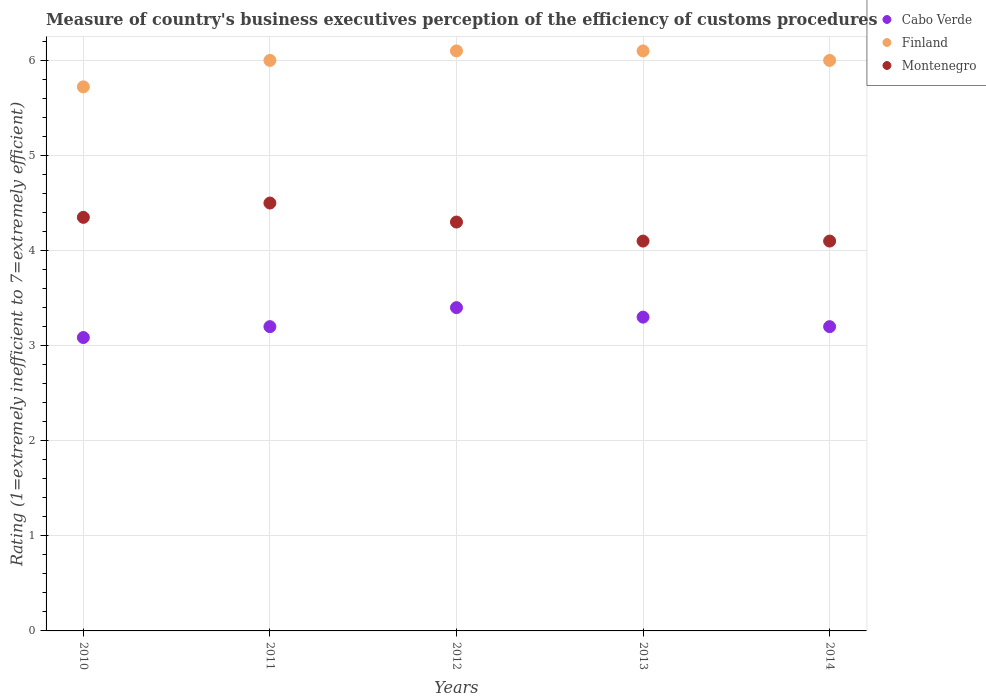What is the rating of the efficiency of customs procedure in Finland in 2011?
Your answer should be compact. 6. Across all years, what is the minimum rating of the efficiency of customs procedure in Cabo Verde?
Ensure brevity in your answer.  3.09. In which year was the rating of the efficiency of customs procedure in Finland maximum?
Ensure brevity in your answer.  2012. In which year was the rating of the efficiency of customs procedure in Cabo Verde minimum?
Offer a terse response. 2010. What is the total rating of the efficiency of customs procedure in Finland in the graph?
Keep it short and to the point. 29.92. What is the difference between the rating of the efficiency of customs procedure in Montenegro in 2011 and the rating of the efficiency of customs procedure in Cabo Verde in 2014?
Give a very brief answer. 1.3. What is the average rating of the efficiency of customs procedure in Montenegro per year?
Keep it short and to the point. 4.27. In the year 2011, what is the difference between the rating of the efficiency of customs procedure in Finland and rating of the efficiency of customs procedure in Cabo Verde?
Your answer should be very brief. 2.8. In how many years, is the rating of the efficiency of customs procedure in Montenegro greater than 5.4?
Make the answer very short. 0. What is the ratio of the rating of the efficiency of customs procedure in Finland in 2013 to that in 2014?
Provide a succinct answer. 1.02. Is the rating of the efficiency of customs procedure in Finland in 2010 less than that in 2011?
Provide a short and direct response. Yes. What is the difference between the highest and the lowest rating of the efficiency of customs procedure in Cabo Verde?
Make the answer very short. 0.31. In how many years, is the rating of the efficiency of customs procedure in Cabo Verde greater than the average rating of the efficiency of customs procedure in Cabo Verde taken over all years?
Offer a very short reply. 2. Is the sum of the rating of the efficiency of customs procedure in Finland in 2011 and 2014 greater than the maximum rating of the efficiency of customs procedure in Cabo Verde across all years?
Give a very brief answer. Yes. Does the rating of the efficiency of customs procedure in Finland monotonically increase over the years?
Offer a very short reply. No. Is the rating of the efficiency of customs procedure in Finland strictly less than the rating of the efficiency of customs procedure in Montenegro over the years?
Offer a very short reply. No. How many dotlines are there?
Provide a succinct answer. 3. Are the values on the major ticks of Y-axis written in scientific E-notation?
Give a very brief answer. No. Does the graph contain any zero values?
Offer a very short reply. No. Does the graph contain grids?
Keep it short and to the point. Yes. How many legend labels are there?
Make the answer very short. 3. What is the title of the graph?
Provide a short and direct response. Measure of country's business executives perception of the efficiency of customs procedures. What is the label or title of the Y-axis?
Your response must be concise. Rating (1=extremely inefficient to 7=extremely efficient). What is the Rating (1=extremely inefficient to 7=extremely efficient) of Cabo Verde in 2010?
Your answer should be compact. 3.09. What is the Rating (1=extremely inefficient to 7=extremely efficient) of Finland in 2010?
Provide a succinct answer. 5.72. What is the Rating (1=extremely inefficient to 7=extremely efficient) in Montenegro in 2010?
Keep it short and to the point. 4.35. What is the Rating (1=extremely inefficient to 7=extremely efficient) in Cabo Verde in 2011?
Provide a succinct answer. 3.2. What is the Rating (1=extremely inefficient to 7=extremely efficient) in Finland in 2011?
Provide a succinct answer. 6. What is the Rating (1=extremely inefficient to 7=extremely efficient) in Montenegro in 2011?
Your answer should be very brief. 4.5. What is the Rating (1=extremely inefficient to 7=extremely efficient) in Cabo Verde in 2012?
Offer a very short reply. 3.4. What is the Rating (1=extremely inefficient to 7=extremely efficient) in Montenegro in 2012?
Provide a short and direct response. 4.3. What is the Rating (1=extremely inefficient to 7=extremely efficient) of Cabo Verde in 2013?
Offer a very short reply. 3.3. What is the Rating (1=extremely inefficient to 7=extremely efficient) of Finland in 2013?
Provide a short and direct response. 6.1. What is the Rating (1=extremely inefficient to 7=extremely efficient) in Montenegro in 2013?
Provide a succinct answer. 4.1. What is the Rating (1=extremely inefficient to 7=extremely efficient) in Finland in 2014?
Your answer should be compact. 6. Across all years, what is the maximum Rating (1=extremely inefficient to 7=extremely efficient) of Cabo Verde?
Your answer should be very brief. 3.4. Across all years, what is the maximum Rating (1=extremely inefficient to 7=extremely efficient) in Finland?
Ensure brevity in your answer.  6.1. Across all years, what is the minimum Rating (1=extremely inefficient to 7=extremely efficient) in Cabo Verde?
Keep it short and to the point. 3.09. Across all years, what is the minimum Rating (1=extremely inefficient to 7=extremely efficient) in Finland?
Your answer should be very brief. 5.72. Across all years, what is the minimum Rating (1=extremely inefficient to 7=extremely efficient) in Montenegro?
Make the answer very short. 4.1. What is the total Rating (1=extremely inefficient to 7=extremely efficient) of Cabo Verde in the graph?
Give a very brief answer. 16.19. What is the total Rating (1=extremely inefficient to 7=extremely efficient) of Finland in the graph?
Keep it short and to the point. 29.92. What is the total Rating (1=extremely inefficient to 7=extremely efficient) in Montenegro in the graph?
Provide a succinct answer. 21.35. What is the difference between the Rating (1=extremely inefficient to 7=extremely efficient) in Cabo Verde in 2010 and that in 2011?
Your answer should be very brief. -0.11. What is the difference between the Rating (1=extremely inefficient to 7=extremely efficient) of Finland in 2010 and that in 2011?
Offer a very short reply. -0.28. What is the difference between the Rating (1=extremely inefficient to 7=extremely efficient) in Montenegro in 2010 and that in 2011?
Ensure brevity in your answer.  -0.15. What is the difference between the Rating (1=extremely inefficient to 7=extremely efficient) in Cabo Verde in 2010 and that in 2012?
Give a very brief answer. -0.31. What is the difference between the Rating (1=extremely inefficient to 7=extremely efficient) of Finland in 2010 and that in 2012?
Make the answer very short. -0.38. What is the difference between the Rating (1=extremely inefficient to 7=extremely efficient) in Montenegro in 2010 and that in 2012?
Your answer should be very brief. 0.05. What is the difference between the Rating (1=extremely inefficient to 7=extremely efficient) of Cabo Verde in 2010 and that in 2013?
Provide a short and direct response. -0.21. What is the difference between the Rating (1=extremely inefficient to 7=extremely efficient) of Finland in 2010 and that in 2013?
Provide a succinct answer. -0.38. What is the difference between the Rating (1=extremely inefficient to 7=extremely efficient) in Montenegro in 2010 and that in 2013?
Ensure brevity in your answer.  0.25. What is the difference between the Rating (1=extremely inefficient to 7=extremely efficient) in Cabo Verde in 2010 and that in 2014?
Your answer should be compact. -0.11. What is the difference between the Rating (1=extremely inefficient to 7=extremely efficient) of Finland in 2010 and that in 2014?
Give a very brief answer. -0.28. What is the difference between the Rating (1=extremely inefficient to 7=extremely efficient) of Montenegro in 2010 and that in 2014?
Keep it short and to the point. 0.25. What is the difference between the Rating (1=extremely inefficient to 7=extremely efficient) in Montenegro in 2011 and that in 2012?
Ensure brevity in your answer.  0.2. What is the difference between the Rating (1=extremely inefficient to 7=extremely efficient) of Cabo Verde in 2011 and that in 2014?
Provide a short and direct response. 0. What is the difference between the Rating (1=extremely inefficient to 7=extremely efficient) in Finland in 2011 and that in 2014?
Provide a succinct answer. 0. What is the difference between the Rating (1=extremely inefficient to 7=extremely efficient) in Montenegro in 2011 and that in 2014?
Give a very brief answer. 0.4. What is the difference between the Rating (1=extremely inefficient to 7=extremely efficient) of Cabo Verde in 2012 and that in 2013?
Provide a short and direct response. 0.1. What is the difference between the Rating (1=extremely inefficient to 7=extremely efficient) in Montenegro in 2012 and that in 2013?
Your answer should be compact. 0.2. What is the difference between the Rating (1=extremely inefficient to 7=extremely efficient) in Montenegro in 2012 and that in 2014?
Your answer should be compact. 0.2. What is the difference between the Rating (1=extremely inefficient to 7=extremely efficient) of Cabo Verde in 2013 and that in 2014?
Your response must be concise. 0.1. What is the difference between the Rating (1=extremely inefficient to 7=extremely efficient) of Finland in 2013 and that in 2014?
Your response must be concise. 0.1. What is the difference between the Rating (1=extremely inefficient to 7=extremely efficient) of Montenegro in 2013 and that in 2014?
Offer a terse response. 0. What is the difference between the Rating (1=extremely inefficient to 7=extremely efficient) of Cabo Verde in 2010 and the Rating (1=extremely inefficient to 7=extremely efficient) of Finland in 2011?
Offer a very short reply. -2.91. What is the difference between the Rating (1=extremely inefficient to 7=extremely efficient) of Cabo Verde in 2010 and the Rating (1=extremely inefficient to 7=extremely efficient) of Montenegro in 2011?
Provide a succinct answer. -1.41. What is the difference between the Rating (1=extremely inefficient to 7=extremely efficient) of Finland in 2010 and the Rating (1=extremely inefficient to 7=extremely efficient) of Montenegro in 2011?
Offer a very short reply. 1.22. What is the difference between the Rating (1=extremely inefficient to 7=extremely efficient) in Cabo Verde in 2010 and the Rating (1=extremely inefficient to 7=extremely efficient) in Finland in 2012?
Offer a terse response. -3.01. What is the difference between the Rating (1=extremely inefficient to 7=extremely efficient) of Cabo Verde in 2010 and the Rating (1=extremely inefficient to 7=extremely efficient) of Montenegro in 2012?
Your answer should be very brief. -1.21. What is the difference between the Rating (1=extremely inefficient to 7=extremely efficient) in Finland in 2010 and the Rating (1=extremely inefficient to 7=extremely efficient) in Montenegro in 2012?
Your response must be concise. 1.42. What is the difference between the Rating (1=extremely inefficient to 7=extremely efficient) of Cabo Verde in 2010 and the Rating (1=extremely inefficient to 7=extremely efficient) of Finland in 2013?
Ensure brevity in your answer.  -3.01. What is the difference between the Rating (1=extremely inefficient to 7=extremely efficient) of Cabo Verde in 2010 and the Rating (1=extremely inefficient to 7=extremely efficient) of Montenegro in 2013?
Make the answer very short. -1.01. What is the difference between the Rating (1=extremely inefficient to 7=extremely efficient) in Finland in 2010 and the Rating (1=extremely inefficient to 7=extremely efficient) in Montenegro in 2013?
Provide a succinct answer. 1.62. What is the difference between the Rating (1=extremely inefficient to 7=extremely efficient) of Cabo Verde in 2010 and the Rating (1=extremely inefficient to 7=extremely efficient) of Finland in 2014?
Ensure brevity in your answer.  -2.91. What is the difference between the Rating (1=extremely inefficient to 7=extremely efficient) in Cabo Verde in 2010 and the Rating (1=extremely inefficient to 7=extremely efficient) in Montenegro in 2014?
Offer a terse response. -1.01. What is the difference between the Rating (1=extremely inefficient to 7=extremely efficient) in Finland in 2010 and the Rating (1=extremely inefficient to 7=extremely efficient) in Montenegro in 2014?
Offer a very short reply. 1.62. What is the difference between the Rating (1=extremely inefficient to 7=extremely efficient) of Cabo Verde in 2011 and the Rating (1=extremely inefficient to 7=extremely efficient) of Montenegro in 2012?
Provide a succinct answer. -1.1. What is the difference between the Rating (1=extremely inefficient to 7=extremely efficient) in Finland in 2011 and the Rating (1=extremely inefficient to 7=extremely efficient) in Montenegro in 2012?
Ensure brevity in your answer.  1.7. What is the difference between the Rating (1=extremely inefficient to 7=extremely efficient) of Cabo Verde in 2011 and the Rating (1=extremely inefficient to 7=extremely efficient) of Finland in 2013?
Your answer should be compact. -2.9. What is the difference between the Rating (1=extremely inefficient to 7=extremely efficient) of Cabo Verde in 2011 and the Rating (1=extremely inefficient to 7=extremely efficient) of Montenegro in 2013?
Your answer should be very brief. -0.9. What is the difference between the Rating (1=extremely inefficient to 7=extremely efficient) of Finland in 2011 and the Rating (1=extremely inefficient to 7=extremely efficient) of Montenegro in 2013?
Offer a terse response. 1.9. What is the difference between the Rating (1=extremely inefficient to 7=extremely efficient) in Cabo Verde in 2011 and the Rating (1=extremely inefficient to 7=extremely efficient) in Finland in 2014?
Give a very brief answer. -2.8. What is the difference between the Rating (1=extremely inefficient to 7=extremely efficient) of Finland in 2011 and the Rating (1=extremely inefficient to 7=extremely efficient) of Montenegro in 2014?
Make the answer very short. 1.9. What is the difference between the Rating (1=extremely inefficient to 7=extremely efficient) of Cabo Verde in 2012 and the Rating (1=extremely inefficient to 7=extremely efficient) of Finland in 2013?
Your answer should be very brief. -2.7. What is the difference between the Rating (1=extremely inefficient to 7=extremely efficient) of Finland in 2012 and the Rating (1=extremely inefficient to 7=extremely efficient) of Montenegro in 2013?
Make the answer very short. 2. What is the difference between the Rating (1=extremely inefficient to 7=extremely efficient) of Cabo Verde in 2012 and the Rating (1=extremely inefficient to 7=extremely efficient) of Montenegro in 2014?
Your answer should be very brief. -0.7. What is the difference between the Rating (1=extremely inefficient to 7=extremely efficient) of Finland in 2012 and the Rating (1=extremely inefficient to 7=extremely efficient) of Montenegro in 2014?
Make the answer very short. 2. What is the difference between the Rating (1=extremely inefficient to 7=extremely efficient) of Cabo Verde in 2013 and the Rating (1=extremely inefficient to 7=extremely efficient) of Finland in 2014?
Offer a very short reply. -2.7. What is the difference between the Rating (1=extremely inefficient to 7=extremely efficient) in Cabo Verde in 2013 and the Rating (1=extremely inefficient to 7=extremely efficient) in Montenegro in 2014?
Make the answer very short. -0.8. What is the average Rating (1=extremely inefficient to 7=extremely efficient) in Cabo Verde per year?
Your answer should be very brief. 3.24. What is the average Rating (1=extremely inefficient to 7=extremely efficient) of Finland per year?
Provide a short and direct response. 5.98. What is the average Rating (1=extremely inefficient to 7=extremely efficient) in Montenegro per year?
Keep it short and to the point. 4.27. In the year 2010, what is the difference between the Rating (1=extremely inefficient to 7=extremely efficient) of Cabo Verde and Rating (1=extremely inefficient to 7=extremely efficient) of Finland?
Offer a very short reply. -2.64. In the year 2010, what is the difference between the Rating (1=extremely inefficient to 7=extremely efficient) in Cabo Verde and Rating (1=extremely inefficient to 7=extremely efficient) in Montenegro?
Offer a terse response. -1.26. In the year 2010, what is the difference between the Rating (1=extremely inefficient to 7=extremely efficient) of Finland and Rating (1=extremely inefficient to 7=extremely efficient) of Montenegro?
Your answer should be very brief. 1.37. In the year 2011, what is the difference between the Rating (1=extremely inefficient to 7=extremely efficient) of Cabo Verde and Rating (1=extremely inefficient to 7=extremely efficient) of Montenegro?
Your answer should be very brief. -1.3. In the year 2012, what is the difference between the Rating (1=extremely inefficient to 7=extremely efficient) of Finland and Rating (1=extremely inefficient to 7=extremely efficient) of Montenegro?
Offer a terse response. 1.8. In the year 2013, what is the difference between the Rating (1=extremely inefficient to 7=extremely efficient) in Cabo Verde and Rating (1=extremely inefficient to 7=extremely efficient) in Finland?
Ensure brevity in your answer.  -2.8. In the year 2013, what is the difference between the Rating (1=extremely inefficient to 7=extremely efficient) of Cabo Verde and Rating (1=extremely inefficient to 7=extremely efficient) of Montenegro?
Offer a very short reply. -0.8. In the year 2013, what is the difference between the Rating (1=extremely inefficient to 7=extremely efficient) in Finland and Rating (1=extremely inefficient to 7=extremely efficient) in Montenegro?
Your answer should be compact. 2. In the year 2014, what is the difference between the Rating (1=extremely inefficient to 7=extremely efficient) in Cabo Verde and Rating (1=extremely inefficient to 7=extremely efficient) in Montenegro?
Provide a short and direct response. -0.9. In the year 2014, what is the difference between the Rating (1=extremely inefficient to 7=extremely efficient) in Finland and Rating (1=extremely inefficient to 7=extremely efficient) in Montenegro?
Your answer should be compact. 1.9. What is the ratio of the Rating (1=extremely inefficient to 7=extremely efficient) of Cabo Verde in 2010 to that in 2011?
Ensure brevity in your answer.  0.96. What is the ratio of the Rating (1=extremely inefficient to 7=extremely efficient) of Finland in 2010 to that in 2011?
Provide a short and direct response. 0.95. What is the ratio of the Rating (1=extremely inefficient to 7=extremely efficient) in Montenegro in 2010 to that in 2011?
Provide a short and direct response. 0.97. What is the ratio of the Rating (1=extremely inefficient to 7=extremely efficient) in Cabo Verde in 2010 to that in 2012?
Provide a short and direct response. 0.91. What is the ratio of the Rating (1=extremely inefficient to 7=extremely efficient) in Finland in 2010 to that in 2012?
Your answer should be compact. 0.94. What is the ratio of the Rating (1=extremely inefficient to 7=extremely efficient) in Montenegro in 2010 to that in 2012?
Keep it short and to the point. 1.01. What is the ratio of the Rating (1=extremely inefficient to 7=extremely efficient) in Cabo Verde in 2010 to that in 2013?
Provide a succinct answer. 0.94. What is the ratio of the Rating (1=extremely inefficient to 7=extremely efficient) in Finland in 2010 to that in 2013?
Your answer should be compact. 0.94. What is the ratio of the Rating (1=extremely inefficient to 7=extremely efficient) in Montenegro in 2010 to that in 2013?
Make the answer very short. 1.06. What is the ratio of the Rating (1=extremely inefficient to 7=extremely efficient) of Cabo Verde in 2010 to that in 2014?
Provide a short and direct response. 0.96. What is the ratio of the Rating (1=extremely inefficient to 7=extremely efficient) of Finland in 2010 to that in 2014?
Your response must be concise. 0.95. What is the ratio of the Rating (1=extremely inefficient to 7=extremely efficient) of Montenegro in 2010 to that in 2014?
Provide a succinct answer. 1.06. What is the ratio of the Rating (1=extremely inefficient to 7=extremely efficient) in Finland in 2011 to that in 2012?
Your answer should be very brief. 0.98. What is the ratio of the Rating (1=extremely inefficient to 7=extremely efficient) of Montenegro in 2011 to that in 2012?
Offer a very short reply. 1.05. What is the ratio of the Rating (1=extremely inefficient to 7=extremely efficient) of Cabo Verde in 2011 to that in 2013?
Make the answer very short. 0.97. What is the ratio of the Rating (1=extremely inefficient to 7=extremely efficient) in Finland in 2011 to that in 2013?
Your response must be concise. 0.98. What is the ratio of the Rating (1=extremely inefficient to 7=extremely efficient) of Montenegro in 2011 to that in 2013?
Make the answer very short. 1.1. What is the ratio of the Rating (1=extremely inefficient to 7=extremely efficient) in Cabo Verde in 2011 to that in 2014?
Offer a terse response. 1. What is the ratio of the Rating (1=extremely inefficient to 7=extremely efficient) of Finland in 2011 to that in 2014?
Keep it short and to the point. 1. What is the ratio of the Rating (1=extremely inefficient to 7=extremely efficient) of Montenegro in 2011 to that in 2014?
Your answer should be very brief. 1.1. What is the ratio of the Rating (1=extremely inefficient to 7=extremely efficient) of Cabo Verde in 2012 to that in 2013?
Offer a very short reply. 1.03. What is the ratio of the Rating (1=extremely inefficient to 7=extremely efficient) of Finland in 2012 to that in 2013?
Ensure brevity in your answer.  1. What is the ratio of the Rating (1=extremely inefficient to 7=extremely efficient) in Montenegro in 2012 to that in 2013?
Give a very brief answer. 1.05. What is the ratio of the Rating (1=extremely inefficient to 7=extremely efficient) in Finland in 2012 to that in 2014?
Ensure brevity in your answer.  1.02. What is the ratio of the Rating (1=extremely inefficient to 7=extremely efficient) in Montenegro in 2012 to that in 2014?
Ensure brevity in your answer.  1.05. What is the ratio of the Rating (1=extremely inefficient to 7=extremely efficient) of Cabo Verde in 2013 to that in 2014?
Provide a succinct answer. 1.03. What is the ratio of the Rating (1=extremely inefficient to 7=extremely efficient) of Finland in 2013 to that in 2014?
Your answer should be compact. 1.02. What is the ratio of the Rating (1=extremely inefficient to 7=extremely efficient) in Montenegro in 2013 to that in 2014?
Ensure brevity in your answer.  1. What is the difference between the highest and the second highest Rating (1=extremely inefficient to 7=extremely efficient) in Montenegro?
Your answer should be very brief. 0.15. What is the difference between the highest and the lowest Rating (1=extremely inefficient to 7=extremely efficient) in Cabo Verde?
Make the answer very short. 0.31. What is the difference between the highest and the lowest Rating (1=extremely inefficient to 7=extremely efficient) in Finland?
Ensure brevity in your answer.  0.38. 